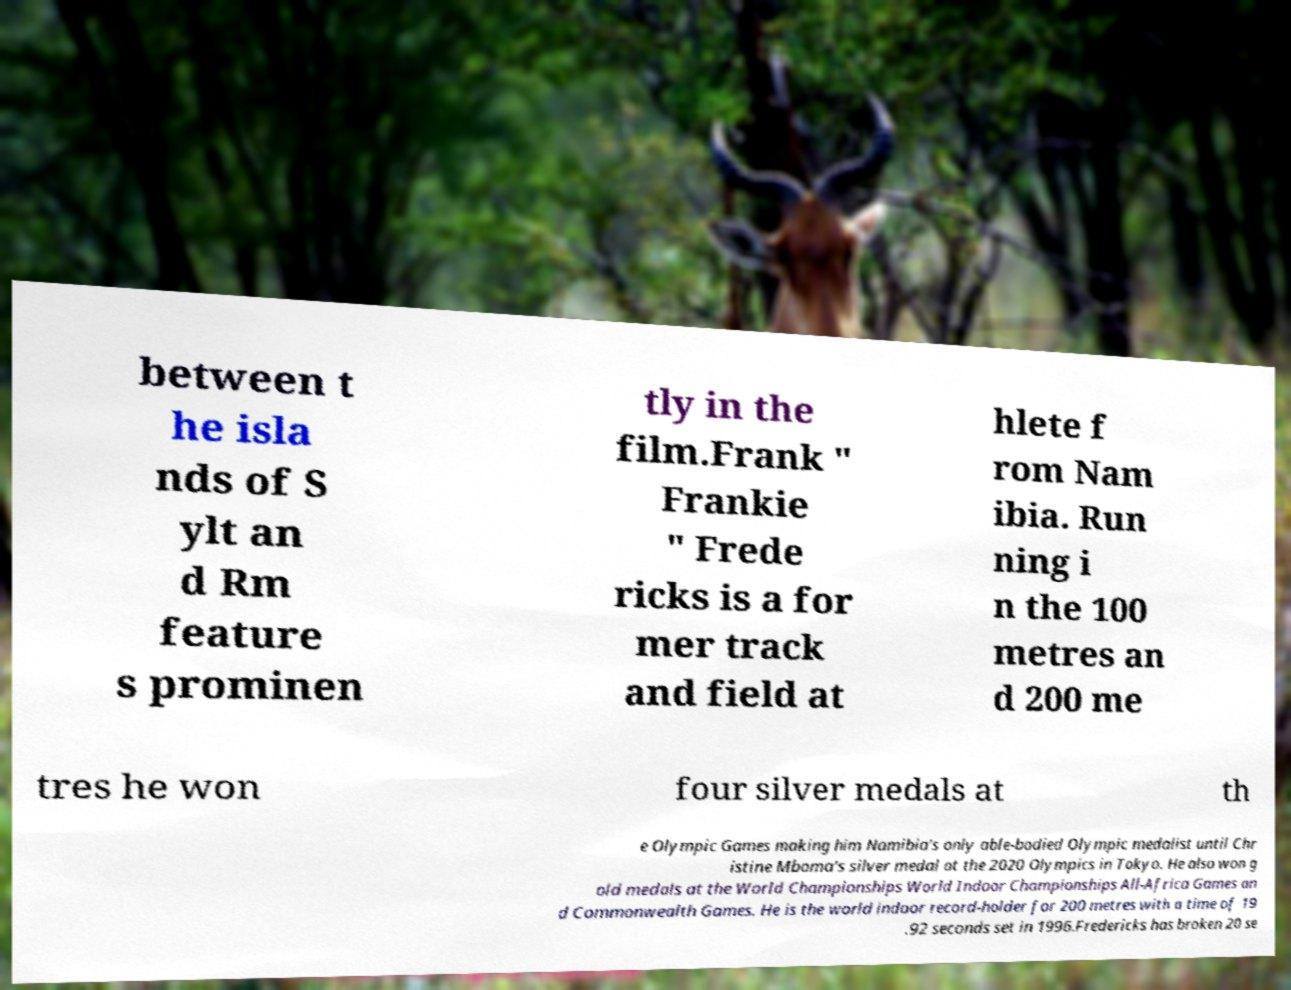Could you assist in decoding the text presented in this image and type it out clearly? between t he isla nds of S ylt an d Rm feature s prominen tly in the film.Frank " Frankie " Frede ricks is a for mer track and field at hlete f rom Nam ibia. Run ning i n the 100 metres an d 200 me tres he won four silver medals at th e Olympic Games making him Namibia's only able-bodied Olympic medalist until Chr istine Mboma's silver medal at the 2020 Olympics in Tokyo. He also won g old medals at the World Championships World Indoor Championships All-Africa Games an d Commonwealth Games. He is the world indoor record-holder for 200 metres with a time of 19 .92 seconds set in 1996.Fredericks has broken 20 se 